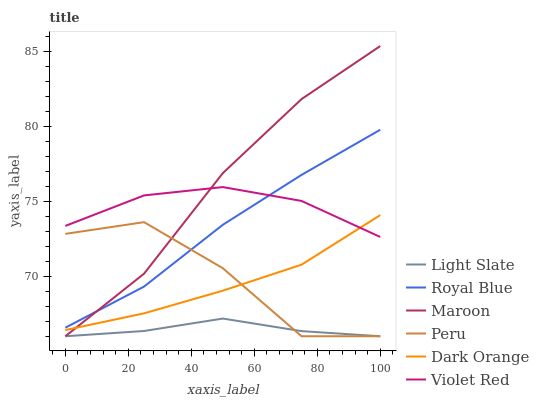Does Light Slate have the minimum area under the curve?
Answer yes or no. Yes. Does Maroon have the maximum area under the curve?
Answer yes or no. Yes. Does Violet Red have the minimum area under the curve?
Answer yes or no. No. Does Violet Red have the maximum area under the curve?
Answer yes or no. No. Is Dark Orange the smoothest?
Answer yes or no. Yes. Is Peru the roughest?
Answer yes or no. Yes. Is Violet Red the smoothest?
Answer yes or no. No. Is Violet Red the roughest?
Answer yes or no. No. Does Violet Red have the lowest value?
Answer yes or no. No. Does Maroon have the highest value?
Answer yes or no. Yes. Does Violet Red have the highest value?
Answer yes or no. No. Is Peru less than Violet Red?
Answer yes or no. Yes. Is Royal Blue greater than Light Slate?
Answer yes or no. Yes. Does Violet Red intersect Maroon?
Answer yes or no. Yes. Is Violet Red less than Maroon?
Answer yes or no. No. Is Violet Red greater than Maroon?
Answer yes or no. No. Does Peru intersect Violet Red?
Answer yes or no. No. 